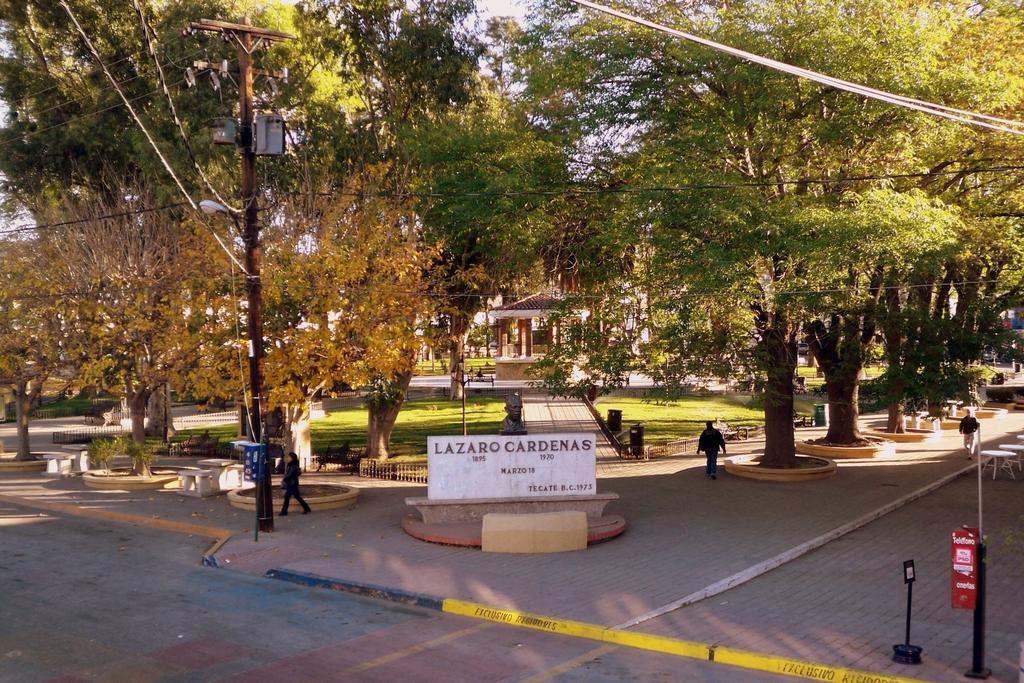Could you give a brief overview of what you see in this image? In the picture I can see people walking on the ground. In the background I can see trees, fence, poles, wires, street lights, grass and some other things. In the background I can see the sky.. 